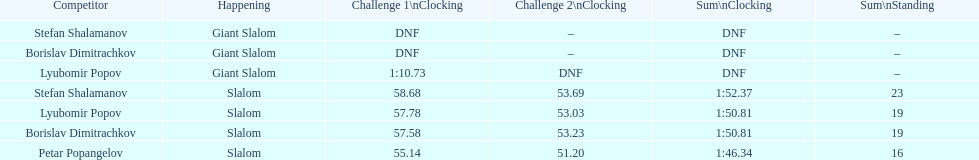In the giant slalom, what is the total number of athletes who finished race one? 1. 